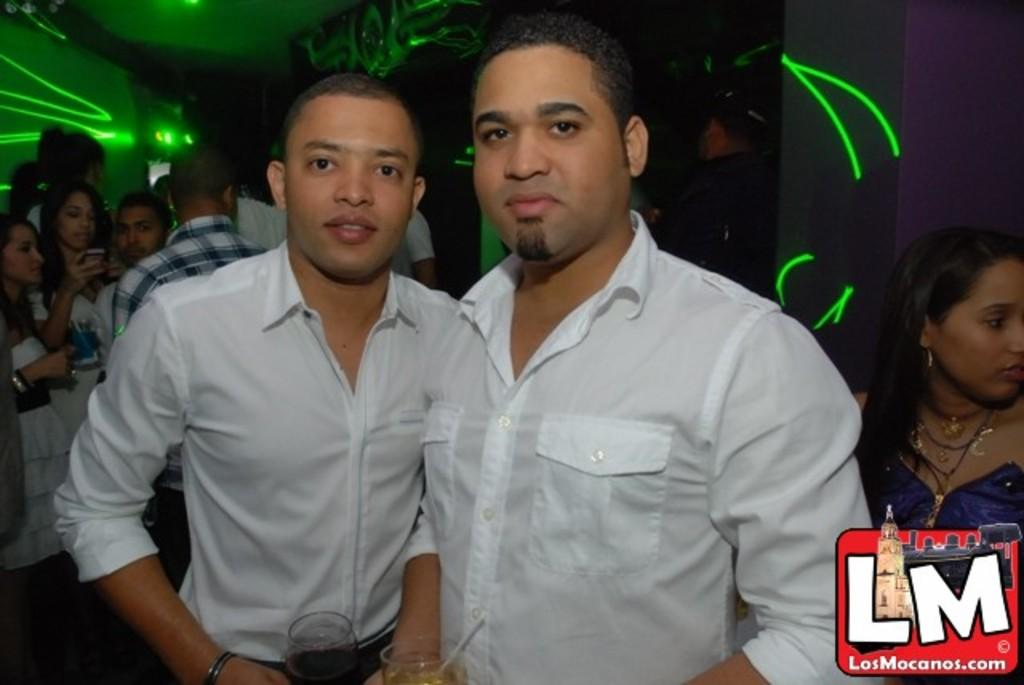What are the two persons holding in the image? The two persons are holding glasses in the image. Can you describe the group of people in the image? There is a group of people standing in the image. What can be seen in the background of the image? There is a wall in the background of the image. Is there any additional information about the image itself? Yes, there is a watermark on the image. What type of eggnog is being served in the glasses held by the two persons in the image? There is no mention of eggnog in the image; the glasses are simply holding an unspecified liquid. What rhythm are the people in the image dancing to? There is no indication that the people in the image are dancing, nor is there any mention of a rhythm. 